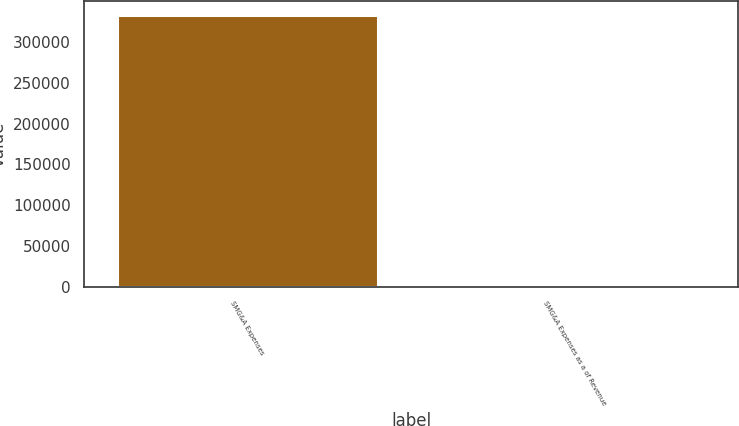<chart> <loc_0><loc_0><loc_500><loc_500><bar_chart><fcel>SMG&A Expenses<fcel>SMG&A Expenses as a of Revenue<nl><fcel>333184<fcel>16.5<nl></chart> 